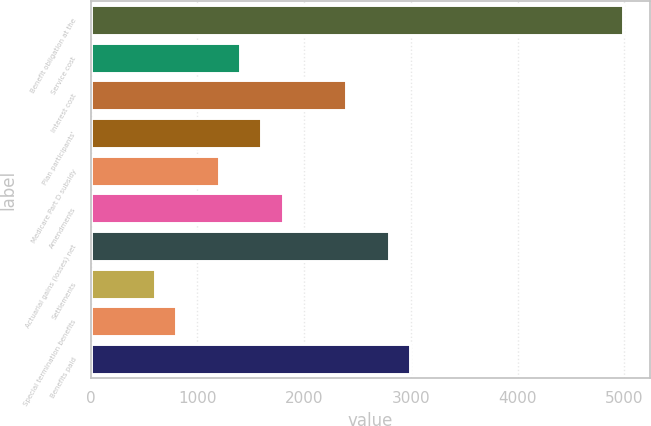Convert chart to OTSL. <chart><loc_0><loc_0><loc_500><loc_500><bar_chart><fcel>Benefit obligation at the<fcel>Service cost<fcel>Interest cost<fcel>Plan participants'<fcel>Medicare Part D subsidy<fcel>Amendments<fcel>Actuarial gains (losses) net<fcel>Settlements<fcel>Special termination benefits<fcel>Benefits paid<nl><fcel>4988.5<fcel>1397.5<fcel>2395<fcel>1597<fcel>1198<fcel>1796.5<fcel>2794<fcel>599.5<fcel>799<fcel>2993.5<nl></chart> 